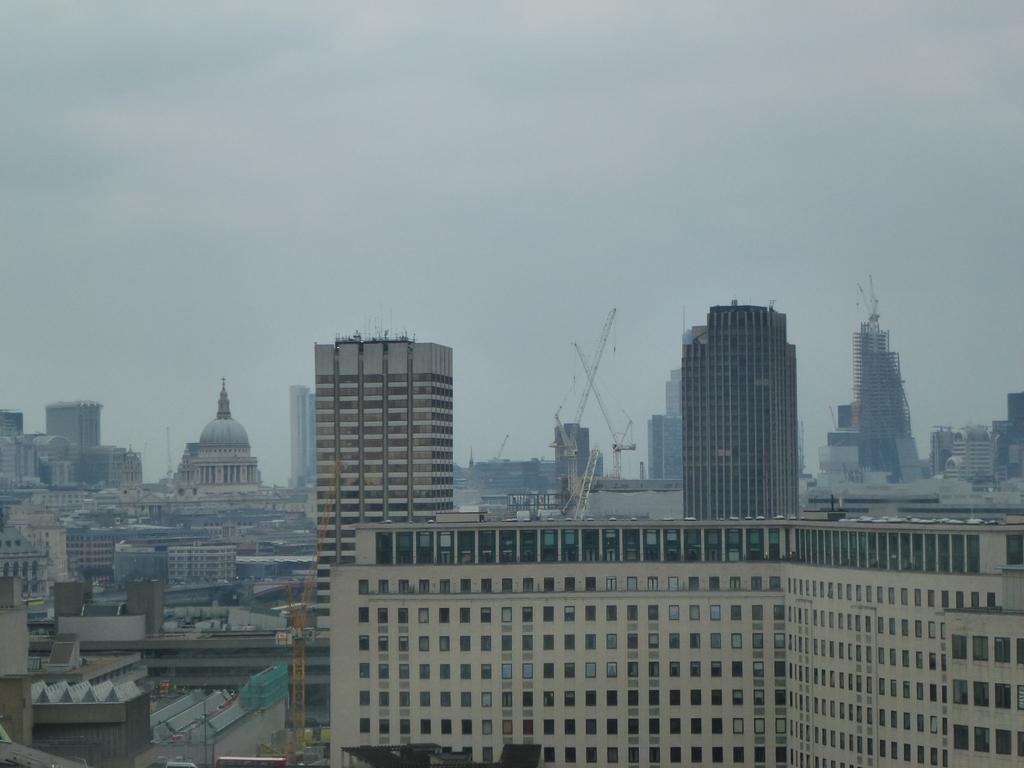Describe this image in one or two sentences. In this image I can see many buildings and the poles. In the background there is a sky. 